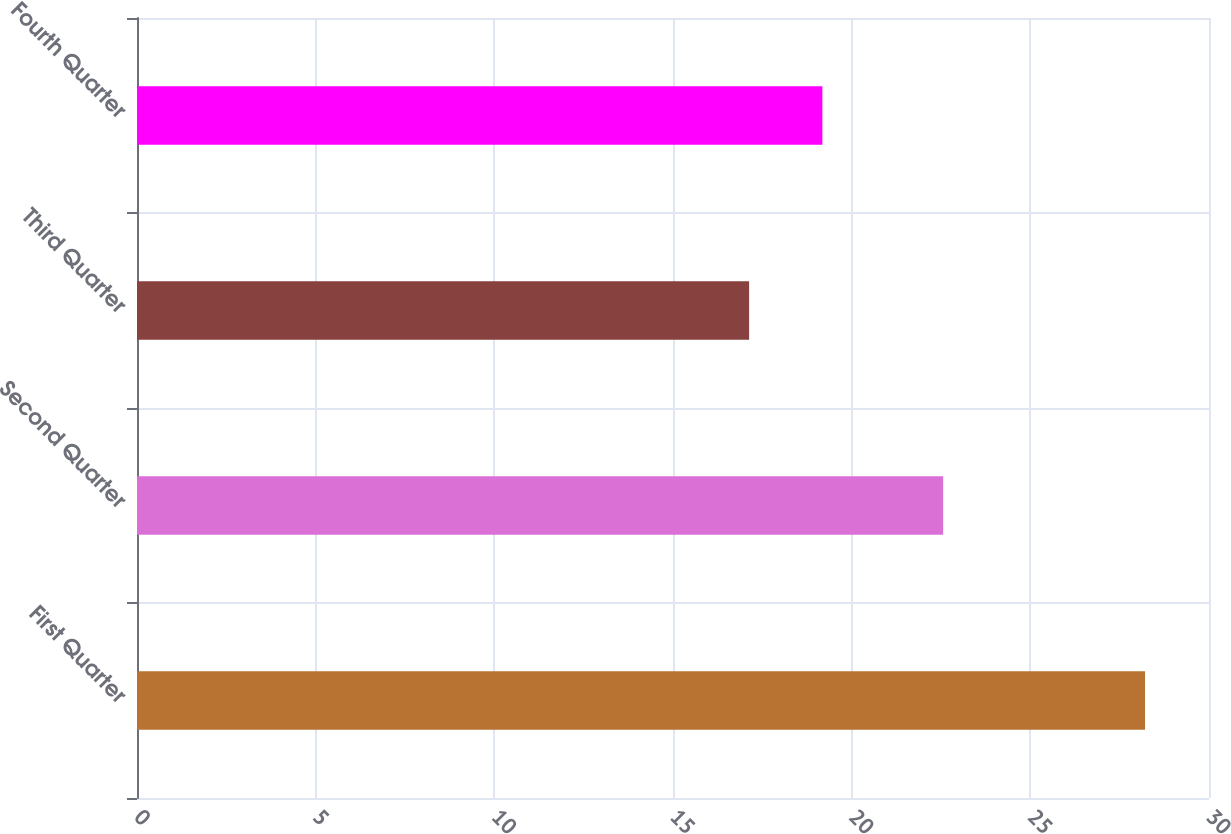<chart> <loc_0><loc_0><loc_500><loc_500><bar_chart><fcel>First Quarter<fcel>Second Quarter<fcel>Third Quarter<fcel>Fourth Quarter<nl><fcel>28.21<fcel>22.56<fcel>17.13<fcel>19.18<nl></chart> 